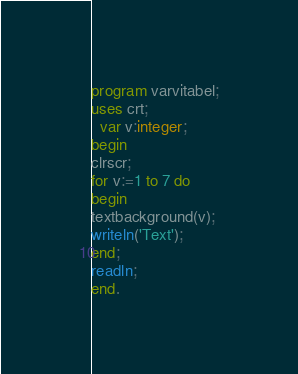<code> <loc_0><loc_0><loc_500><loc_500><_Pascal_>program varvitabel;
uses crt;
  var v:integer;
begin
clrscr;
for v:=1 to 7 do
begin
textbackground(v);
writeln('Text');
end;
readln;
end.</code> 